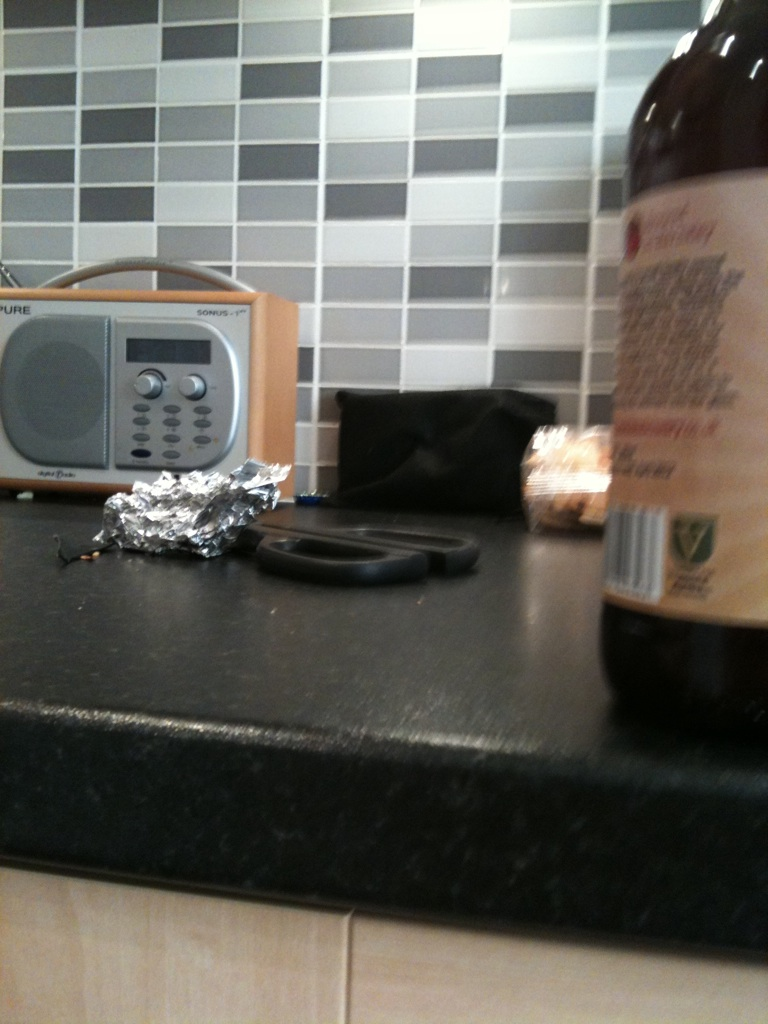If this kitchen counter could talk, what stories would it tell? If this kitchen counter could talk, it would recount tales of jubilant family gatherings filled with laughter and the clinking of dishes. It would share secrets of midnight snacks, whispering about the times the kitchen glowed faintly under the moonlight. The counter might reveal the creative culinary experiments that either ended in delicious success or a comical disaster. It would remember the early mornings when someone would sneak in for a quiet cup of coffee, accompanied by the soft hum of the radio. And amidst these daily rituals, it would highlight the enduring sense of home and togetherness that fills the air. 